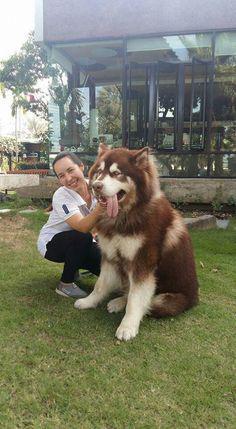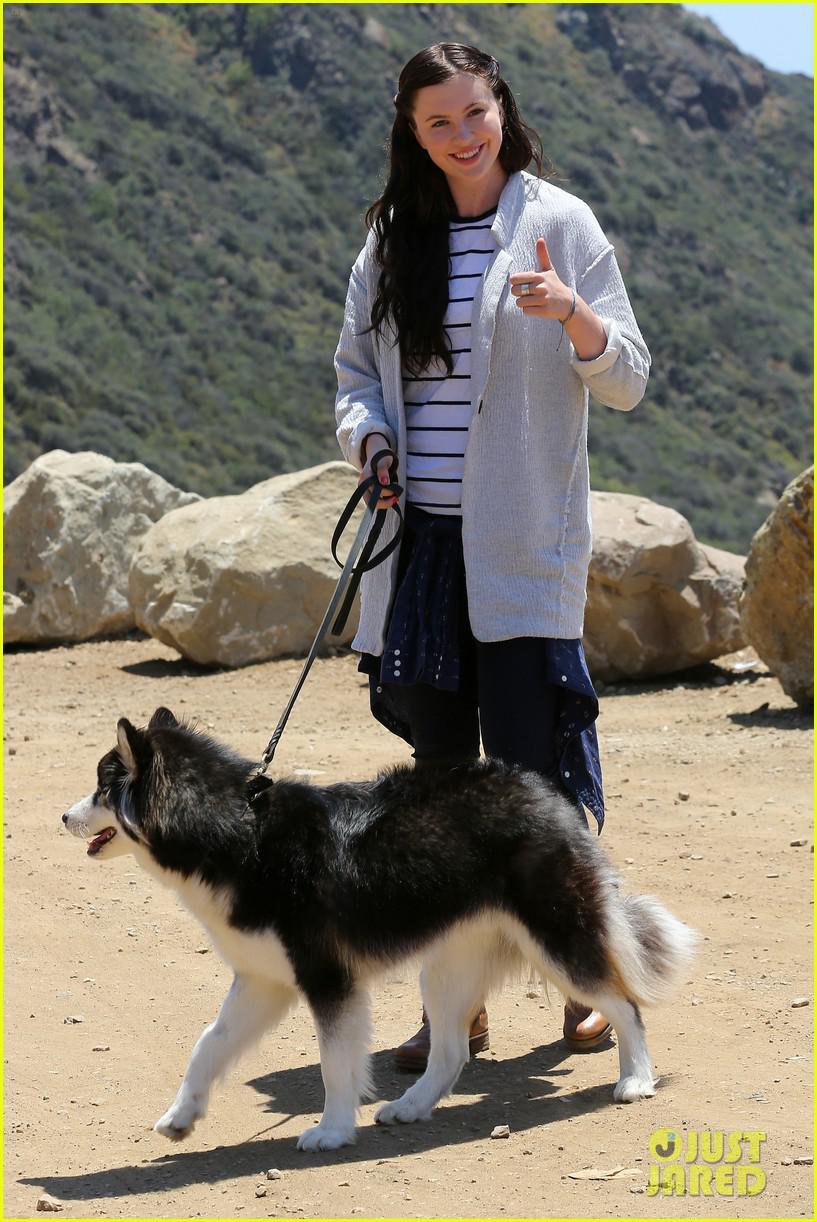The first image is the image on the left, the second image is the image on the right. For the images displayed, is the sentence "There is a person in a green top standing near the dog." factually correct? Answer yes or no. No. The first image is the image on the left, the second image is the image on the right. Assess this claim about the two images: "The right image contains at least two dogs.". Correct or not? Answer yes or no. No. 